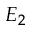<formula> <loc_0><loc_0><loc_500><loc_500>E _ { 2 }</formula> 